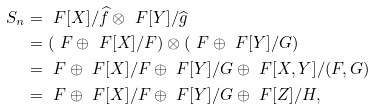<formula> <loc_0><loc_0><loc_500><loc_500>S _ { n } & = \ F [ X ] / \widehat { f } \otimes \ F [ Y ] / \widehat { g } \\ & = ( \ F \oplus \ F [ X ] / F ) \otimes ( \ F \oplus \ F [ Y ] / G ) \\ & = \ F \oplus \ F [ X ] / F \oplus \ F [ Y ] / G \oplus \ F [ X , Y ] / ( F , G ) \\ & = \ F \oplus \ F [ X ] / F \oplus \ F [ Y ] / G \oplus \ F [ Z ] / H ,</formula> 